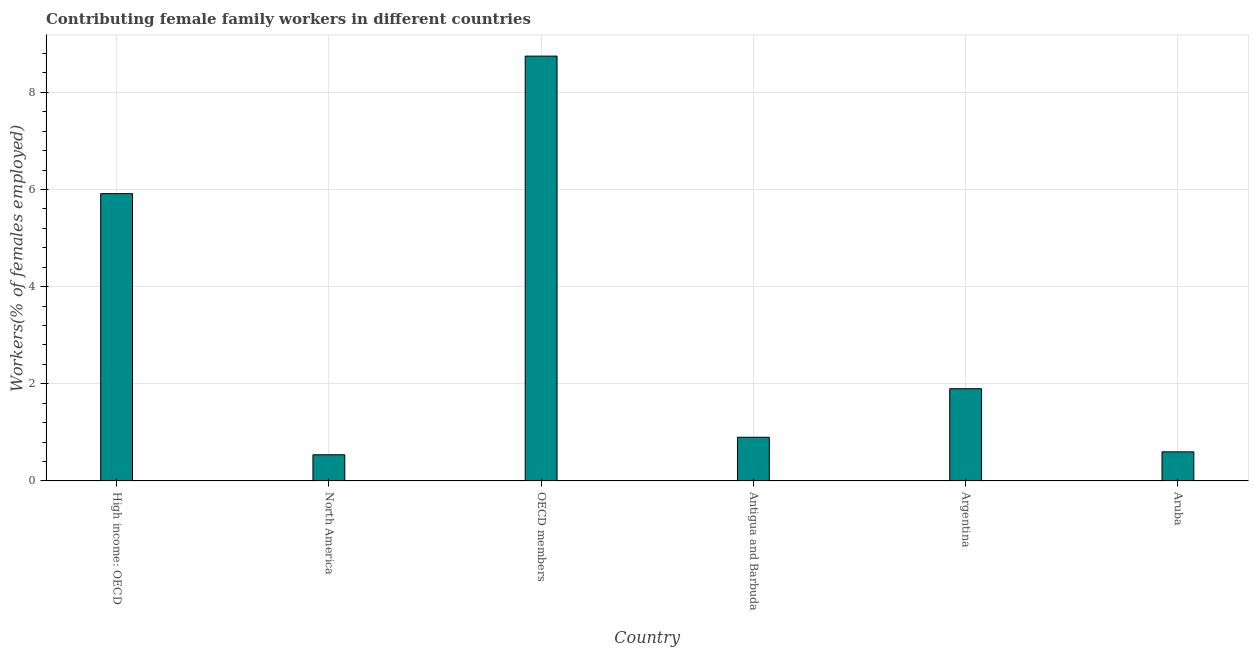Does the graph contain grids?
Provide a succinct answer. Yes. What is the title of the graph?
Your answer should be very brief. Contributing female family workers in different countries. What is the label or title of the Y-axis?
Ensure brevity in your answer.  Workers(% of females employed). What is the contributing female family workers in Antigua and Barbuda?
Your answer should be very brief. 0.9. Across all countries, what is the maximum contributing female family workers?
Make the answer very short. 8.75. Across all countries, what is the minimum contributing female family workers?
Offer a terse response. 0.54. In which country was the contributing female family workers maximum?
Offer a terse response. OECD members. In which country was the contributing female family workers minimum?
Make the answer very short. North America. What is the sum of the contributing female family workers?
Provide a succinct answer. 18.6. What is the average contributing female family workers per country?
Your answer should be very brief. 3.1. What is the median contributing female family workers?
Offer a terse response. 1.4. What is the ratio of the contributing female family workers in High income: OECD to that in North America?
Ensure brevity in your answer.  10.96. Is the difference between the contributing female family workers in Antigua and Barbuda and High income: OECD greater than the difference between any two countries?
Keep it short and to the point. No. What is the difference between the highest and the second highest contributing female family workers?
Make the answer very short. 2.83. What is the difference between the highest and the lowest contributing female family workers?
Your answer should be compact. 8.21. How many bars are there?
Provide a succinct answer. 6. Are the values on the major ticks of Y-axis written in scientific E-notation?
Ensure brevity in your answer.  No. What is the Workers(% of females employed) in High income: OECD?
Provide a succinct answer. 5.92. What is the Workers(% of females employed) of North America?
Give a very brief answer. 0.54. What is the Workers(% of females employed) in OECD members?
Provide a short and direct response. 8.75. What is the Workers(% of females employed) of Antigua and Barbuda?
Your answer should be compact. 0.9. What is the Workers(% of females employed) of Argentina?
Provide a succinct answer. 1.9. What is the Workers(% of females employed) of Aruba?
Give a very brief answer. 0.6. What is the difference between the Workers(% of females employed) in High income: OECD and North America?
Make the answer very short. 5.38. What is the difference between the Workers(% of females employed) in High income: OECD and OECD members?
Provide a short and direct response. -2.83. What is the difference between the Workers(% of females employed) in High income: OECD and Antigua and Barbuda?
Provide a succinct answer. 5.02. What is the difference between the Workers(% of females employed) in High income: OECD and Argentina?
Offer a very short reply. 4.02. What is the difference between the Workers(% of females employed) in High income: OECD and Aruba?
Keep it short and to the point. 5.32. What is the difference between the Workers(% of females employed) in North America and OECD members?
Your answer should be compact. -8.21. What is the difference between the Workers(% of females employed) in North America and Antigua and Barbuda?
Offer a very short reply. -0.36. What is the difference between the Workers(% of females employed) in North America and Argentina?
Keep it short and to the point. -1.36. What is the difference between the Workers(% of females employed) in North America and Aruba?
Ensure brevity in your answer.  -0.06. What is the difference between the Workers(% of females employed) in OECD members and Antigua and Barbuda?
Keep it short and to the point. 7.85. What is the difference between the Workers(% of females employed) in OECD members and Argentina?
Provide a succinct answer. 6.85. What is the difference between the Workers(% of females employed) in OECD members and Aruba?
Offer a very short reply. 8.15. What is the difference between the Workers(% of females employed) in Antigua and Barbuda and Argentina?
Provide a succinct answer. -1. What is the difference between the Workers(% of females employed) in Antigua and Barbuda and Aruba?
Keep it short and to the point. 0.3. What is the difference between the Workers(% of females employed) in Argentina and Aruba?
Your response must be concise. 1.3. What is the ratio of the Workers(% of females employed) in High income: OECD to that in North America?
Offer a terse response. 10.96. What is the ratio of the Workers(% of females employed) in High income: OECD to that in OECD members?
Your answer should be very brief. 0.68. What is the ratio of the Workers(% of females employed) in High income: OECD to that in Antigua and Barbuda?
Your answer should be compact. 6.57. What is the ratio of the Workers(% of females employed) in High income: OECD to that in Argentina?
Offer a terse response. 3.11. What is the ratio of the Workers(% of females employed) in High income: OECD to that in Aruba?
Your answer should be compact. 9.86. What is the ratio of the Workers(% of females employed) in North America to that in OECD members?
Your answer should be compact. 0.06. What is the ratio of the Workers(% of females employed) in North America to that in Argentina?
Keep it short and to the point. 0.28. What is the ratio of the Workers(% of females employed) in OECD members to that in Antigua and Barbuda?
Your answer should be compact. 9.72. What is the ratio of the Workers(% of females employed) in OECD members to that in Argentina?
Your response must be concise. 4.6. What is the ratio of the Workers(% of females employed) in OECD members to that in Aruba?
Provide a succinct answer. 14.58. What is the ratio of the Workers(% of females employed) in Antigua and Barbuda to that in Argentina?
Provide a succinct answer. 0.47. What is the ratio of the Workers(% of females employed) in Antigua and Barbuda to that in Aruba?
Offer a very short reply. 1.5. What is the ratio of the Workers(% of females employed) in Argentina to that in Aruba?
Ensure brevity in your answer.  3.17. 